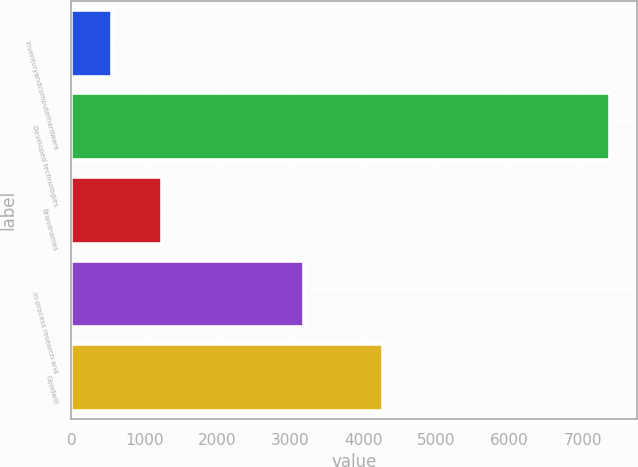Convert chart to OTSL. <chart><loc_0><loc_0><loc_500><loc_500><bar_chart><fcel>Inventoryandcomputerhardware<fcel>Developed technologies<fcel>Brandnames<fcel>In-process research and<fcel>Goodwill<nl><fcel>558<fcel>7380<fcel>1240.2<fcel>3180<fcel>4262<nl></chart> 